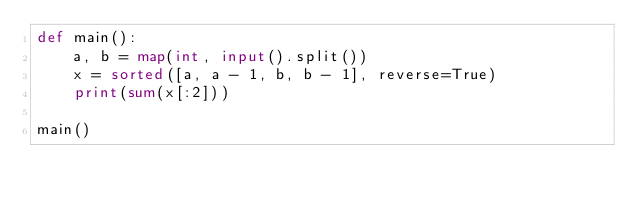<code> <loc_0><loc_0><loc_500><loc_500><_Python_>def main():
    a, b = map(int, input().split())
    x = sorted([a, a - 1, b, b - 1], reverse=True)
    print(sum(x[:2]))

main()
</code> 